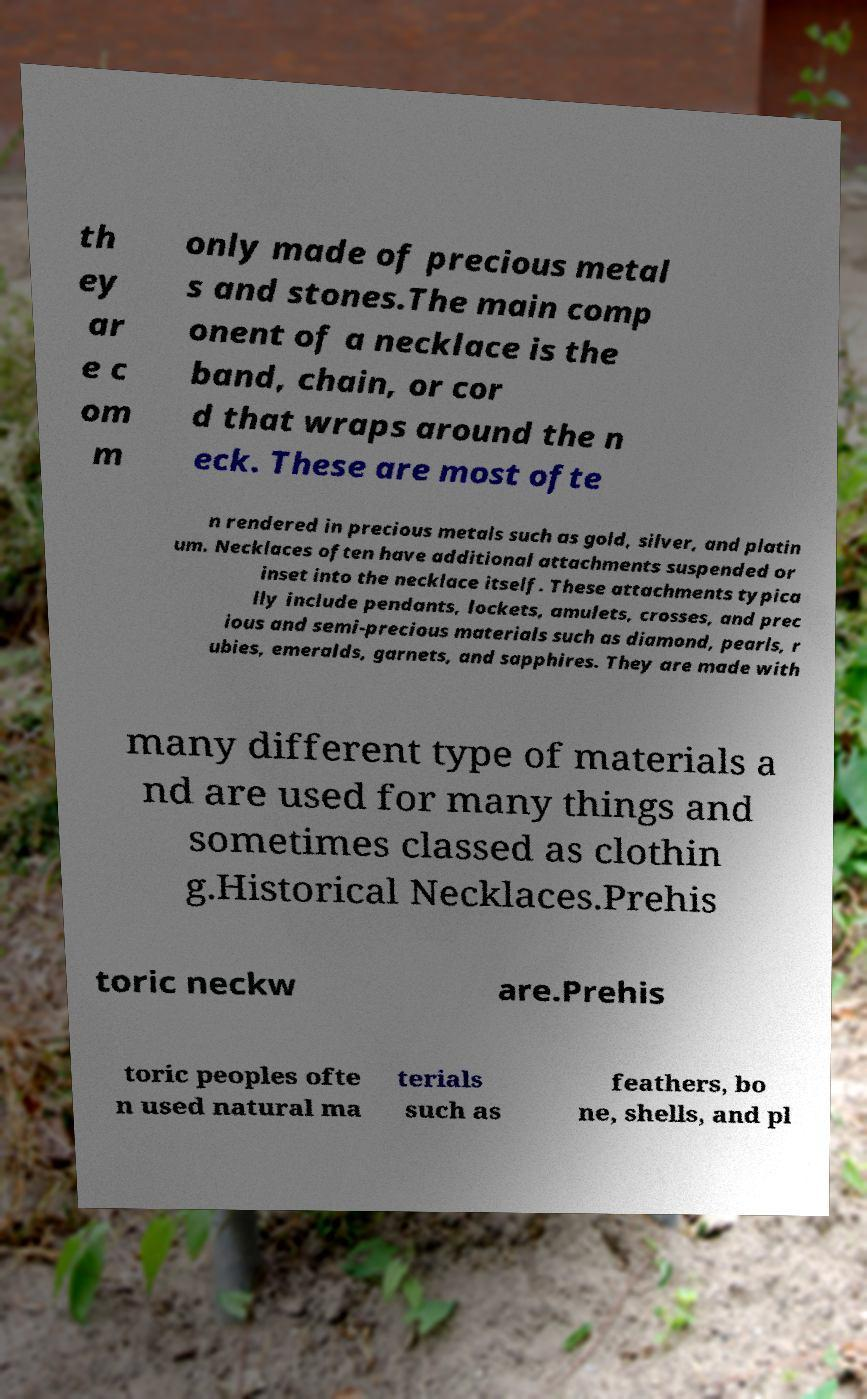Can you read and provide the text displayed in the image?This photo seems to have some interesting text. Can you extract and type it out for me? th ey ar e c om m only made of precious metal s and stones.The main comp onent of a necklace is the band, chain, or cor d that wraps around the n eck. These are most ofte n rendered in precious metals such as gold, silver, and platin um. Necklaces often have additional attachments suspended or inset into the necklace itself. These attachments typica lly include pendants, lockets, amulets, crosses, and prec ious and semi-precious materials such as diamond, pearls, r ubies, emeralds, garnets, and sapphires. They are made with many different type of materials a nd are used for many things and sometimes classed as clothin g.Historical Necklaces.Prehis toric neckw are.Prehis toric peoples ofte n used natural ma terials such as feathers, bo ne, shells, and pl 